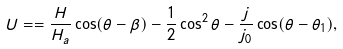Convert formula to latex. <formula><loc_0><loc_0><loc_500><loc_500>U = = \frac { H } { H _ { a } } \cos ( \theta - \beta ) - \frac { 1 } { 2 } \cos ^ { 2 } \theta - \frac { j } { j _ { 0 } } \cos ( \theta - \theta _ { 1 } ) ,</formula> 